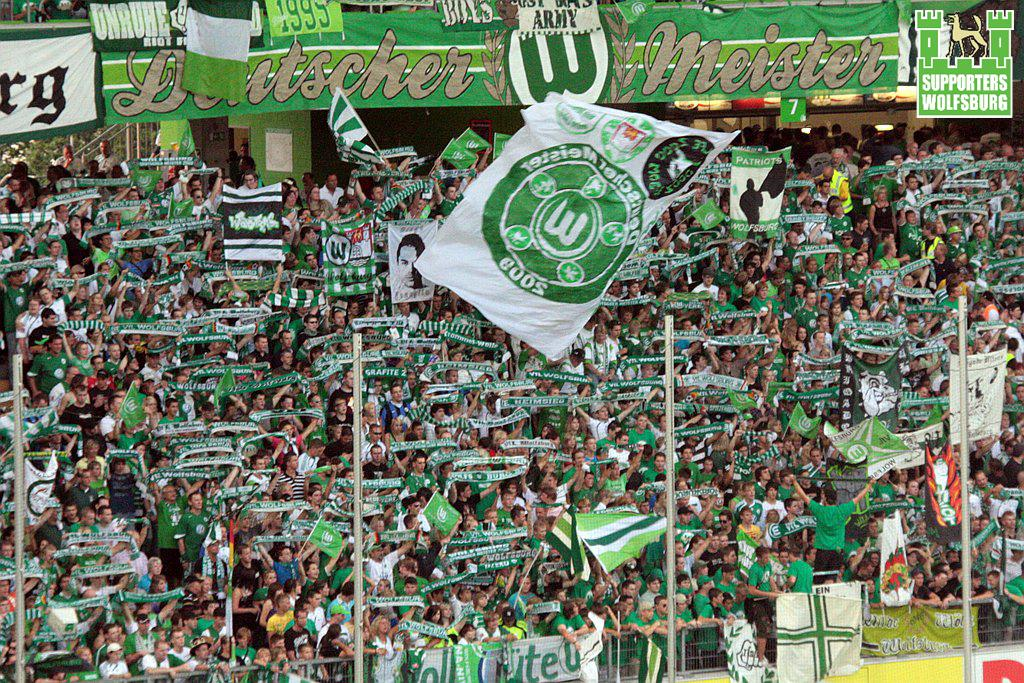How many people are in the image? There is a group of people in the image, but the exact number is not specified. What are some people doing in the image? Some people are holding flags in the image. What can be seen in the background of the image? There are hoardings and lights in the background of the image. What is in front of the group of people? Metal rods and a fence and metal rods are present in front of the group of people. Are there any pins visible on the flags in the image? There is no mention of pins on the flags in the image, so we cannot determine if any are present. Can you see a bag hanging on the fence in the image? There is no bag hanging on the fence in the image. Is there a cobweb visible on the hoardings in the background? There is no mention of a cobweb on the hoardings in the image, so we cannot determine if one is present. 